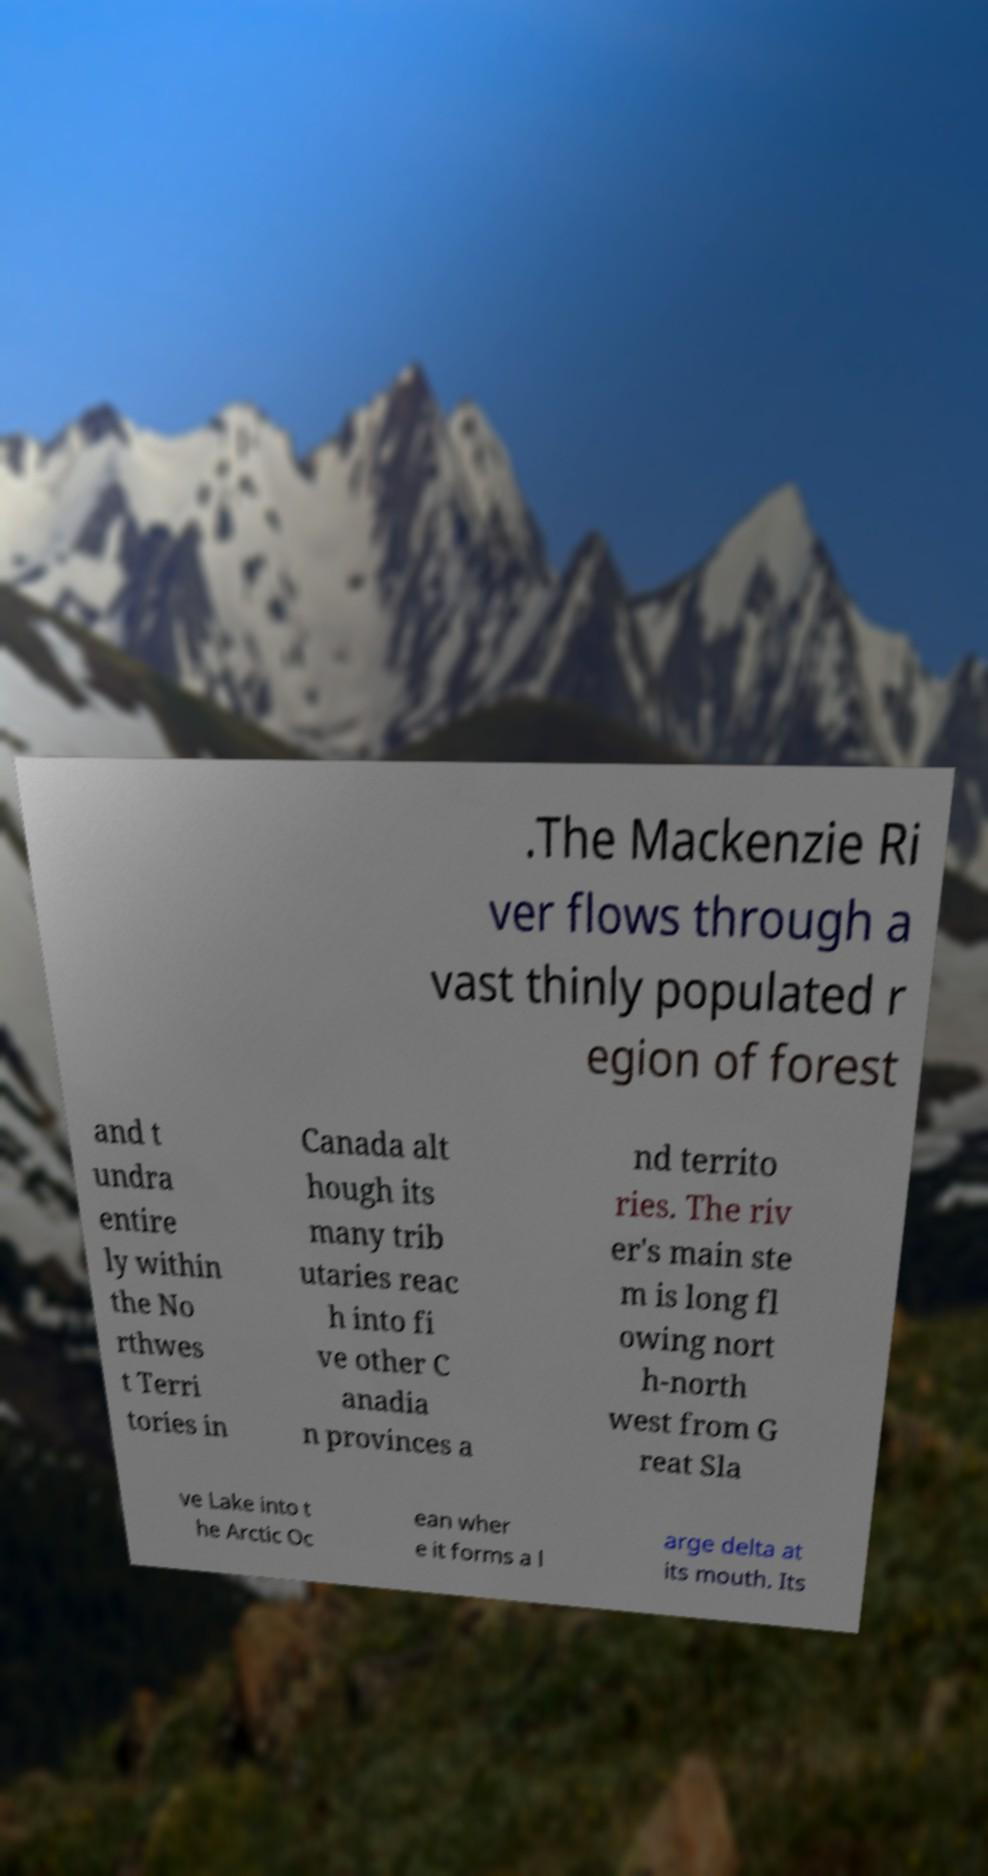Could you extract and type out the text from this image? .The Mackenzie Ri ver flows through a vast thinly populated r egion of forest and t undra entire ly within the No rthwes t Terri tories in Canada alt hough its many trib utaries reac h into fi ve other C anadia n provinces a nd territo ries. The riv er's main ste m is long fl owing nort h-north west from G reat Sla ve Lake into t he Arctic Oc ean wher e it forms a l arge delta at its mouth. Its 